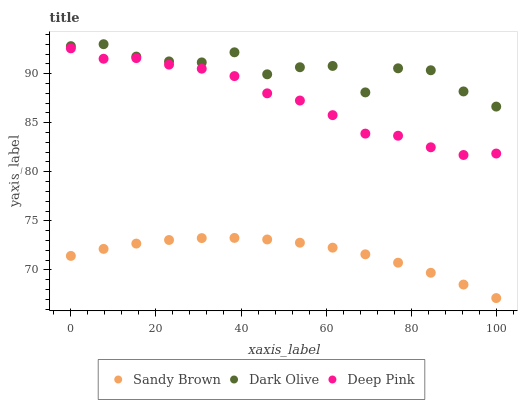Does Sandy Brown have the minimum area under the curve?
Answer yes or no. Yes. Does Dark Olive have the maximum area under the curve?
Answer yes or no. Yes. Does Deep Pink have the minimum area under the curve?
Answer yes or no. No. Does Deep Pink have the maximum area under the curve?
Answer yes or no. No. Is Sandy Brown the smoothest?
Answer yes or no. Yes. Is Dark Olive the roughest?
Answer yes or no. Yes. Is Deep Pink the smoothest?
Answer yes or no. No. Is Deep Pink the roughest?
Answer yes or no. No. Does Sandy Brown have the lowest value?
Answer yes or no. Yes. Does Deep Pink have the lowest value?
Answer yes or no. No. Does Dark Olive have the highest value?
Answer yes or no. Yes. Does Deep Pink have the highest value?
Answer yes or no. No. Is Sandy Brown less than Deep Pink?
Answer yes or no. Yes. Is Deep Pink greater than Sandy Brown?
Answer yes or no. Yes. Does Sandy Brown intersect Deep Pink?
Answer yes or no. No. 